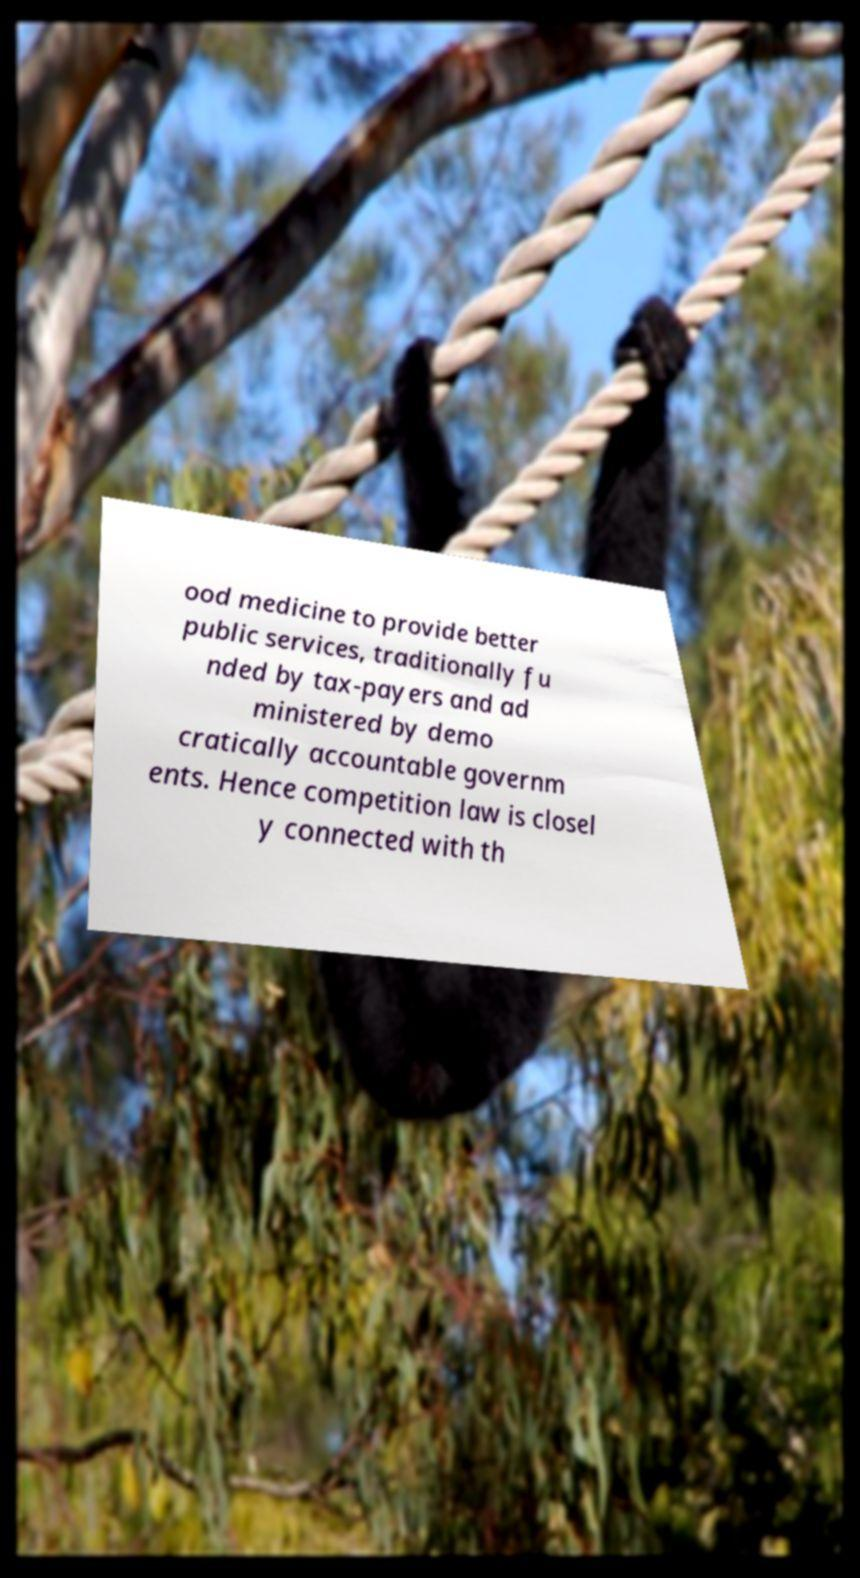Could you assist in decoding the text presented in this image and type it out clearly? ood medicine to provide better public services, traditionally fu nded by tax-payers and ad ministered by demo cratically accountable governm ents. Hence competition law is closel y connected with th 